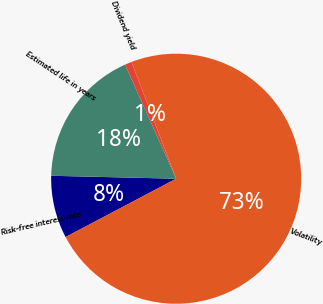<chart> <loc_0><loc_0><loc_500><loc_500><pie_chart><fcel>Risk-free interest rate<fcel>Estimated life in years<fcel>Dividend yield<fcel>Volatility<nl><fcel>8.1%<fcel>17.92%<fcel>0.88%<fcel>73.09%<nl></chart> 